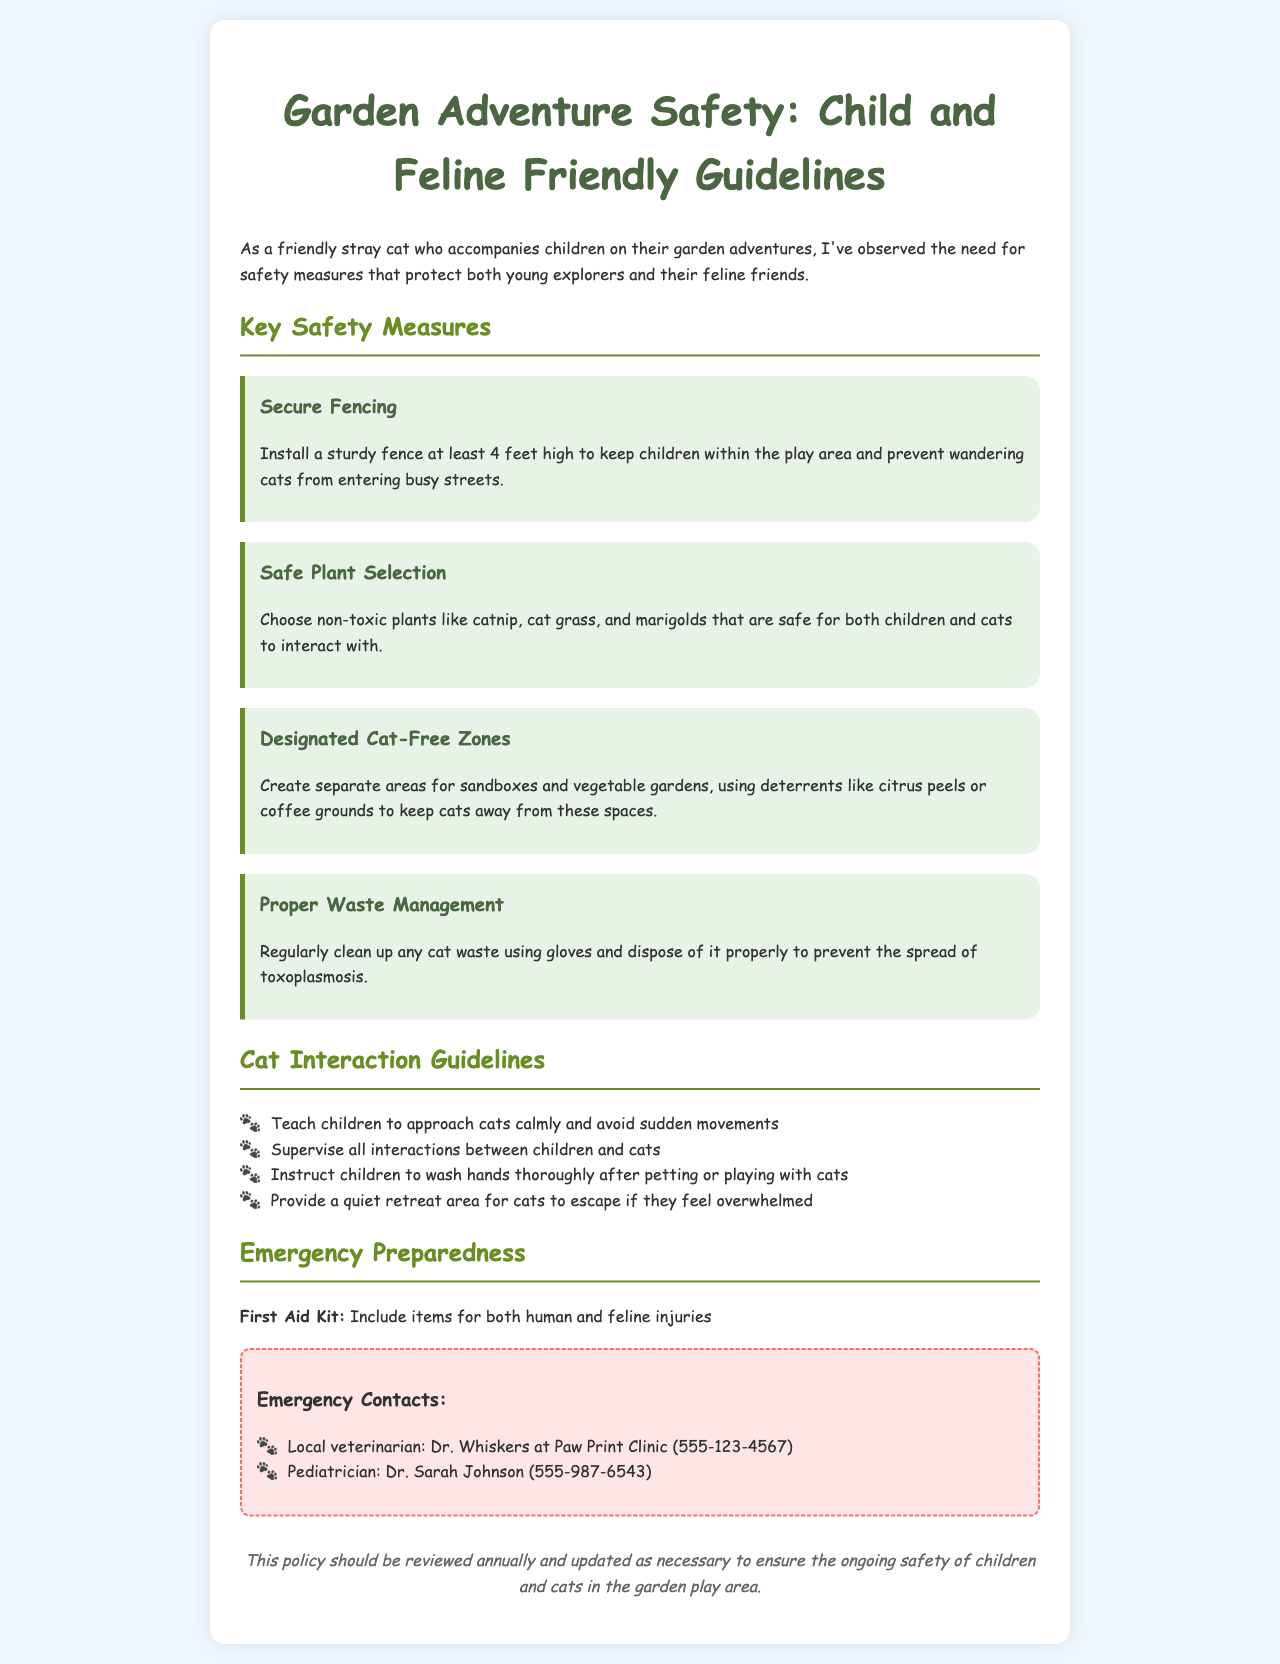What height should the fence be? The document states that a sturdy fence should be at least 4 feet high.
Answer: 4 feet What plants are mentioned as safe for children and cats? Non-toxic plants like catnip, cat grass, and marigolds are safe for interaction.
Answer: catnip, cat grass, marigolds What are the designated areas to keep cats away from? The document specifies sandboxes and vegetable gardens as areas to deter cats.
Answer: sandboxes and vegetable gardens What should be included in the first aid kit? The first aid kit should contain items for both human and feline injuries.
Answer: items for human and feline injuries Who is the local veterinarian mentioned? The document mentions Dr. Whiskers at Paw Print Clinic as the local veterinarian.
Answer: Dr. Whiskers at Paw Print Clinic How often should the policy be reviewed? The policy should be reviewed annually to ensure ongoing safety.
Answer: annually What should children do after interacting with cats? The document instructs children to wash hands thoroughly after petting or playing with cats.
Answer: wash hands thoroughly What is a suggested way to keep cats away from gardens? Deterrents like citrus peels or coffee grounds are suggested to keep cats away.
Answer: citrus peels or coffee grounds 